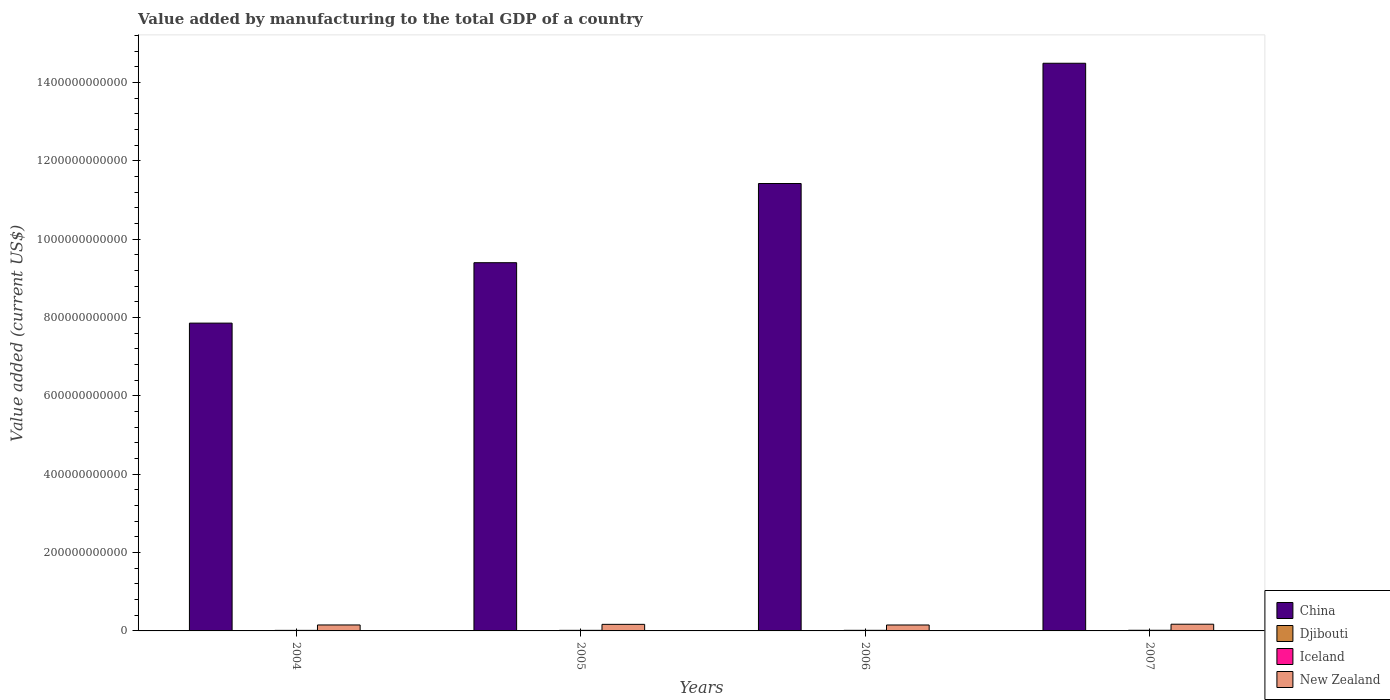How many different coloured bars are there?
Make the answer very short. 4. How many groups of bars are there?
Your response must be concise. 4. How many bars are there on the 1st tick from the right?
Offer a very short reply. 4. In how many cases, is the number of bars for a given year not equal to the number of legend labels?
Your answer should be compact. 0. What is the value added by manufacturing to the total GDP in Iceland in 2004?
Make the answer very short. 1.43e+09. Across all years, what is the maximum value added by manufacturing to the total GDP in Iceland?
Keep it short and to the point. 1.64e+09. Across all years, what is the minimum value added by manufacturing to the total GDP in New Zealand?
Make the answer very short. 1.51e+1. In which year was the value added by manufacturing to the total GDP in Djibouti minimum?
Offer a very short reply. 2004. What is the total value added by manufacturing to the total GDP in China in the graph?
Provide a short and direct response. 4.32e+12. What is the difference between the value added by manufacturing to the total GDP in Iceland in 2004 and that in 2007?
Your answer should be very brief. -2.09e+08. What is the difference between the value added by manufacturing to the total GDP in China in 2007 and the value added by manufacturing to the total GDP in Iceland in 2004?
Ensure brevity in your answer.  1.45e+12. What is the average value added by manufacturing to the total GDP in Djibouti per year?
Your answer should be compact. 1.68e+07. In the year 2007, what is the difference between the value added by manufacturing to the total GDP in Djibouti and value added by manufacturing to the total GDP in Iceland?
Offer a terse response. -1.62e+09. What is the ratio of the value added by manufacturing to the total GDP in Djibouti in 2005 to that in 2006?
Your response must be concise. 0.94. Is the value added by manufacturing to the total GDP in New Zealand in 2006 less than that in 2007?
Your answer should be compact. Yes. What is the difference between the highest and the second highest value added by manufacturing to the total GDP in New Zealand?
Your response must be concise. 3.70e+08. What is the difference between the highest and the lowest value added by manufacturing to the total GDP in Djibouti?
Ensure brevity in your answer.  2.88e+06. Is it the case that in every year, the sum of the value added by manufacturing to the total GDP in New Zealand and value added by manufacturing to the total GDP in Iceland is greater than the sum of value added by manufacturing to the total GDP in China and value added by manufacturing to the total GDP in Djibouti?
Your answer should be compact. Yes. What does the 1st bar from the right in 2004 represents?
Ensure brevity in your answer.  New Zealand. Is it the case that in every year, the sum of the value added by manufacturing to the total GDP in Djibouti and value added by manufacturing to the total GDP in New Zealand is greater than the value added by manufacturing to the total GDP in Iceland?
Offer a very short reply. Yes. How many bars are there?
Keep it short and to the point. 16. Are all the bars in the graph horizontal?
Your answer should be very brief. No. How many years are there in the graph?
Your response must be concise. 4. What is the difference between two consecutive major ticks on the Y-axis?
Give a very brief answer. 2.00e+11. Are the values on the major ticks of Y-axis written in scientific E-notation?
Provide a short and direct response. No. Does the graph contain any zero values?
Provide a succinct answer. No. Where does the legend appear in the graph?
Offer a terse response. Bottom right. What is the title of the graph?
Provide a short and direct response. Value added by manufacturing to the total GDP of a country. Does "Macao" appear as one of the legend labels in the graph?
Keep it short and to the point. No. What is the label or title of the X-axis?
Offer a terse response. Years. What is the label or title of the Y-axis?
Your answer should be very brief. Value added (current US$). What is the Value added (current US$) of China in 2004?
Provide a succinct answer. 7.86e+11. What is the Value added (current US$) in Djibouti in 2004?
Give a very brief answer. 1.54e+07. What is the Value added (current US$) in Iceland in 2004?
Your answer should be compact. 1.43e+09. What is the Value added (current US$) in New Zealand in 2004?
Your response must be concise. 1.52e+1. What is the Value added (current US$) in China in 2005?
Ensure brevity in your answer.  9.40e+11. What is the Value added (current US$) in Djibouti in 2005?
Provide a short and direct response. 1.63e+07. What is the Value added (current US$) of Iceland in 2005?
Make the answer very short. 1.48e+09. What is the Value added (current US$) of New Zealand in 2005?
Your answer should be very brief. 1.68e+1. What is the Value added (current US$) of China in 2006?
Offer a terse response. 1.14e+12. What is the Value added (current US$) of Djibouti in 2006?
Give a very brief answer. 1.73e+07. What is the Value added (current US$) of Iceland in 2006?
Keep it short and to the point. 1.51e+09. What is the Value added (current US$) in New Zealand in 2006?
Keep it short and to the point. 1.51e+1. What is the Value added (current US$) of China in 2007?
Your answer should be compact. 1.45e+12. What is the Value added (current US$) in Djibouti in 2007?
Your answer should be very brief. 1.83e+07. What is the Value added (current US$) in Iceland in 2007?
Ensure brevity in your answer.  1.64e+09. What is the Value added (current US$) in New Zealand in 2007?
Offer a very short reply. 1.71e+1. Across all years, what is the maximum Value added (current US$) in China?
Make the answer very short. 1.45e+12. Across all years, what is the maximum Value added (current US$) of Djibouti?
Make the answer very short. 1.83e+07. Across all years, what is the maximum Value added (current US$) in Iceland?
Give a very brief answer. 1.64e+09. Across all years, what is the maximum Value added (current US$) in New Zealand?
Offer a very short reply. 1.71e+1. Across all years, what is the minimum Value added (current US$) in China?
Give a very brief answer. 7.86e+11. Across all years, what is the minimum Value added (current US$) of Djibouti?
Your answer should be very brief. 1.54e+07. Across all years, what is the minimum Value added (current US$) of Iceland?
Provide a succinct answer. 1.43e+09. Across all years, what is the minimum Value added (current US$) of New Zealand?
Make the answer very short. 1.51e+1. What is the total Value added (current US$) in China in the graph?
Your response must be concise. 4.32e+12. What is the total Value added (current US$) of Djibouti in the graph?
Give a very brief answer. 6.73e+07. What is the total Value added (current US$) of Iceland in the graph?
Offer a terse response. 6.06e+09. What is the total Value added (current US$) of New Zealand in the graph?
Ensure brevity in your answer.  6.42e+1. What is the difference between the Value added (current US$) in China in 2004 and that in 2005?
Your answer should be very brief. -1.54e+11. What is the difference between the Value added (current US$) in Djibouti in 2004 and that in 2005?
Make the answer very short. -8.77e+05. What is the difference between the Value added (current US$) of Iceland in 2004 and that in 2005?
Provide a short and direct response. -5.56e+07. What is the difference between the Value added (current US$) of New Zealand in 2004 and that in 2005?
Your answer should be compact. -1.55e+09. What is the difference between the Value added (current US$) of China in 2004 and that in 2006?
Ensure brevity in your answer.  -3.56e+11. What is the difference between the Value added (current US$) of Djibouti in 2004 and that in 2006?
Offer a terse response. -1.83e+06. What is the difference between the Value added (current US$) of Iceland in 2004 and that in 2006?
Your response must be concise. -8.86e+07. What is the difference between the Value added (current US$) in New Zealand in 2004 and that in 2006?
Your response must be concise. 5.43e+07. What is the difference between the Value added (current US$) in China in 2004 and that in 2007?
Offer a very short reply. -6.63e+11. What is the difference between the Value added (current US$) in Djibouti in 2004 and that in 2007?
Keep it short and to the point. -2.88e+06. What is the difference between the Value added (current US$) of Iceland in 2004 and that in 2007?
Your response must be concise. -2.09e+08. What is the difference between the Value added (current US$) of New Zealand in 2004 and that in 2007?
Make the answer very short. -1.92e+09. What is the difference between the Value added (current US$) of China in 2005 and that in 2006?
Offer a terse response. -2.02e+11. What is the difference between the Value added (current US$) of Djibouti in 2005 and that in 2006?
Keep it short and to the point. -9.53e+05. What is the difference between the Value added (current US$) in Iceland in 2005 and that in 2006?
Offer a terse response. -3.30e+07. What is the difference between the Value added (current US$) of New Zealand in 2005 and that in 2006?
Your answer should be very brief. 1.61e+09. What is the difference between the Value added (current US$) in China in 2005 and that in 2007?
Provide a succinct answer. -5.09e+11. What is the difference between the Value added (current US$) of Djibouti in 2005 and that in 2007?
Your answer should be very brief. -2.00e+06. What is the difference between the Value added (current US$) of Iceland in 2005 and that in 2007?
Keep it short and to the point. -1.54e+08. What is the difference between the Value added (current US$) in New Zealand in 2005 and that in 2007?
Your answer should be very brief. -3.70e+08. What is the difference between the Value added (current US$) in China in 2006 and that in 2007?
Make the answer very short. -3.07e+11. What is the difference between the Value added (current US$) of Djibouti in 2006 and that in 2007?
Your answer should be compact. -1.05e+06. What is the difference between the Value added (current US$) in Iceland in 2006 and that in 2007?
Ensure brevity in your answer.  -1.21e+08. What is the difference between the Value added (current US$) of New Zealand in 2006 and that in 2007?
Ensure brevity in your answer.  -1.98e+09. What is the difference between the Value added (current US$) in China in 2004 and the Value added (current US$) in Djibouti in 2005?
Give a very brief answer. 7.86e+11. What is the difference between the Value added (current US$) in China in 2004 and the Value added (current US$) in Iceland in 2005?
Keep it short and to the point. 7.84e+11. What is the difference between the Value added (current US$) in China in 2004 and the Value added (current US$) in New Zealand in 2005?
Keep it short and to the point. 7.69e+11. What is the difference between the Value added (current US$) of Djibouti in 2004 and the Value added (current US$) of Iceland in 2005?
Ensure brevity in your answer.  -1.47e+09. What is the difference between the Value added (current US$) of Djibouti in 2004 and the Value added (current US$) of New Zealand in 2005?
Your response must be concise. -1.67e+1. What is the difference between the Value added (current US$) in Iceland in 2004 and the Value added (current US$) in New Zealand in 2005?
Provide a short and direct response. -1.53e+1. What is the difference between the Value added (current US$) in China in 2004 and the Value added (current US$) in Djibouti in 2006?
Offer a terse response. 7.86e+11. What is the difference between the Value added (current US$) in China in 2004 and the Value added (current US$) in Iceland in 2006?
Your response must be concise. 7.84e+11. What is the difference between the Value added (current US$) of China in 2004 and the Value added (current US$) of New Zealand in 2006?
Offer a very short reply. 7.71e+11. What is the difference between the Value added (current US$) in Djibouti in 2004 and the Value added (current US$) in Iceland in 2006?
Make the answer very short. -1.50e+09. What is the difference between the Value added (current US$) of Djibouti in 2004 and the Value added (current US$) of New Zealand in 2006?
Provide a succinct answer. -1.51e+1. What is the difference between the Value added (current US$) in Iceland in 2004 and the Value added (current US$) in New Zealand in 2006?
Provide a succinct answer. -1.37e+1. What is the difference between the Value added (current US$) in China in 2004 and the Value added (current US$) in Djibouti in 2007?
Your response must be concise. 7.86e+11. What is the difference between the Value added (current US$) of China in 2004 and the Value added (current US$) of Iceland in 2007?
Provide a short and direct response. 7.84e+11. What is the difference between the Value added (current US$) in China in 2004 and the Value added (current US$) in New Zealand in 2007?
Make the answer very short. 7.69e+11. What is the difference between the Value added (current US$) in Djibouti in 2004 and the Value added (current US$) in Iceland in 2007?
Offer a terse response. -1.62e+09. What is the difference between the Value added (current US$) of Djibouti in 2004 and the Value added (current US$) of New Zealand in 2007?
Give a very brief answer. -1.71e+1. What is the difference between the Value added (current US$) of Iceland in 2004 and the Value added (current US$) of New Zealand in 2007?
Your answer should be compact. -1.57e+1. What is the difference between the Value added (current US$) in China in 2005 and the Value added (current US$) in Djibouti in 2006?
Offer a terse response. 9.40e+11. What is the difference between the Value added (current US$) in China in 2005 and the Value added (current US$) in Iceland in 2006?
Give a very brief answer. 9.39e+11. What is the difference between the Value added (current US$) of China in 2005 and the Value added (current US$) of New Zealand in 2006?
Ensure brevity in your answer.  9.25e+11. What is the difference between the Value added (current US$) in Djibouti in 2005 and the Value added (current US$) in Iceland in 2006?
Provide a succinct answer. -1.50e+09. What is the difference between the Value added (current US$) of Djibouti in 2005 and the Value added (current US$) of New Zealand in 2006?
Your answer should be compact. -1.51e+1. What is the difference between the Value added (current US$) in Iceland in 2005 and the Value added (current US$) in New Zealand in 2006?
Your answer should be very brief. -1.37e+1. What is the difference between the Value added (current US$) in China in 2005 and the Value added (current US$) in Djibouti in 2007?
Offer a terse response. 9.40e+11. What is the difference between the Value added (current US$) of China in 2005 and the Value added (current US$) of Iceland in 2007?
Offer a very short reply. 9.38e+11. What is the difference between the Value added (current US$) of China in 2005 and the Value added (current US$) of New Zealand in 2007?
Your answer should be very brief. 9.23e+11. What is the difference between the Value added (current US$) of Djibouti in 2005 and the Value added (current US$) of Iceland in 2007?
Ensure brevity in your answer.  -1.62e+09. What is the difference between the Value added (current US$) of Djibouti in 2005 and the Value added (current US$) of New Zealand in 2007?
Offer a very short reply. -1.71e+1. What is the difference between the Value added (current US$) in Iceland in 2005 and the Value added (current US$) in New Zealand in 2007?
Offer a terse response. -1.56e+1. What is the difference between the Value added (current US$) in China in 2006 and the Value added (current US$) in Djibouti in 2007?
Make the answer very short. 1.14e+12. What is the difference between the Value added (current US$) in China in 2006 and the Value added (current US$) in Iceland in 2007?
Your answer should be compact. 1.14e+12. What is the difference between the Value added (current US$) in China in 2006 and the Value added (current US$) in New Zealand in 2007?
Offer a very short reply. 1.13e+12. What is the difference between the Value added (current US$) in Djibouti in 2006 and the Value added (current US$) in Iceland in 2007?
Your answer should be very brief. -1.62e+09. What is the difference between the Value added (current US$) in Djibouti in 2006 and the Value added (current US$) in New Zealand in 2007?
Your answer should be compact. -1.71e+1. What is the difference between the Value added (current US$) of Iceland in 2006 and the Value added (current US$) of New Zealand in 2007?
Offer a very short reply. -1.56e+1. What is the average Value added (current US$) in China per year?
Your answer should be very brief. 1.08e+12. What is the average Value added (current US$) in Djibouti per year?
Your response must be concise. 1.68e+07. What is the average Value added (current US$) of Iceland per year?
Keep it short and to the point. 1.51e+09. What is the average Value added (current US$) in New Zealand per year?
Your answer should be very brief. 1.61e+1. In the year 2004, what is the difference between the Value added (current US$) of China and Value added (current US$) of Djibouti?
Offer a terse response. 7.86e+11. In the year 2004, what is the difference between the Value added (current US$) of China and Value added (current US$) of Iceland?
Your answer should be very brief. 7.84e+11. In the year 2004, what is the difference between the Value added (current US$) in China and Value added (current US$) in New Zealand?
Ensure brevity in your answer.  7.71e+11. In the year 2004, what is the difference between the Value added (current US$) in Djibouti and Value added (current US$) in Iceland?
Offer a terse response. -1.41e+09. In the year 2004, what is the difference between the Value added (current US$) in Djibouti and Value added (current US$) in New Zealand?
Provide a short and direct response. -1.52e+1. In the year 2004, what is the difference between the Value added (current US$) in Iceland and Value added (current US$) in New Zealand?
Offer a very short reply. -1.38e+1. In the year 2005, what is the difference between the Value added (current US$) in China and Value added (current US$) in Djibouti?
Provide a succinct answer. 9.40e+11. In the year 2005, what is the difference between the Value added (current US$) in China and Value added (current US$) in Iceland?
Your answer should be compact. 9.39e+11. In the year 2005, what is the difference between the Value added (current US$) of China and Value added (current US$) of New Zealand?
Offer a very short reply. 9.23e+11. In the year 2005, what is the difference between the Value added (current US$) in Djibouti and Value added (current US$) in Iceland?
Your response must be concise. -1.47e+09. In the year 2005, what is the difference between the Value added (current US$) of Djibouti and Value added (current US$) of New Zealand?
Give a very brief answer. -1.67e+1. In the year 2005, what is the difference between the Value added (current US$) of Iceland and Value added (current US$) of New Zealand?
Your answer should be compact. -1.53e+1. In the year 2006, what is the difference between the Value added (current US$) in China and Value added (current US$) in Djibouti?
Provide a short and direct response. 1.14e+12. In the year 2006, what is the difference between the Value added (current US$) of China and Value added (current US$) of Iceland?
Keep it short and to the point. 1.14e+12. In the year 2006, what is the difference between the Value added (current US$) in China and Value added (current US$) in New Zealand?
Your answer should be compact. 1.13e+12. In the year 2006, what is the difference between the Value added (current US$) in Djibouti and Value added (current US$) in Iceland?
Keep it short and to the point. -1.50e+09. In the year 2006, what is the difference between the Value added (current US$) of Djibouti and Value added (current US$) of New Zealand?
Ensure brevity in your answer.  -1.51e+1. In the year 2006, what is the difference between the Value added (current US$) in Iceland and Value added (current US$) in New Zealand?
Give a very brief answer. -1.36e+1. In the year 2007, what is the difference between the Value added (current US$) in China and Value added (current US$) in Djibouti?
Your response must be concise. 1.45e+12. In the year 2007, what is the difference between the Value added (current US$) of China and Value added (current US$) of Iceland?
Make the answer very short. 1.45e+12. In the year 2007, what is the difference between the Value added (current US$) of China and Value added (current US$) of New Zealand?
Provide a short and direct response. 1.43e+12. In the year 2007, what is the difference between the Value added (current US$) in Djibouti and Value added (current US$) in Iceland?
Offer a very short reply. -1.62e+09. In the year 2007, what is the difference between the Value added (current US$) in Djibouti and Value added (current US$) in New Zealand?
Offer a terse response. -1.71e+1. In the year 2007, what is the difference between the Value added (current US$) of Iceland and Value added (current US$) of New Zealand?
Offer a very short reply. -1.55e+1. What is the ratio of the Value added (current US$) in China in 2004 to that in 2005?
Give a very brief answer. 0.84. What is the ratio of the Value added (current US$) of Djibouti in 2004 to that in 2005?
Provide a short and direct response. 0.95. What is the ratio of the Value added (current US$) in Iceland in 2004 to that in 2005?
Make the answer very short. 0.96. What is the ratio of the Value added (current US$) of New Zealand in 2004 to that in 2005?
Make the answer very short. 0.91. What is the ratio of the Value added (current US$) in China in 2004 to that in 2006?
Offer a terse response. 0.69. What is the ratio of the Value added (current US$) of Djibouti in 2004 to that in 2006?
Ensure brevity in your answer.  0.89. What is the ratio of the Value added (current US$) of Iceland in 2004 to that in 2006?
Provide a succinct answer. 0.94. What is the ratio of the Value added (current US$) of China in 2004 to that in 2007?
Offer a terse response. 0.54. What is the ratio of the Value added (current US$) in Djibouti in 2004 to that in 2007?
Provide a succinct answer. 0.84. What is the ratio of the Value added (current US$) in Iceland in 2004 to that in 2007?
Your response must be concise. 0.87. What is the ratio of the Value added (current US$) of New Zealand in 2004 to that in 2007?
Provide a succinct answer. 0.89. What is the ratio of the Value added (current US$) in China in 2005 to that in 2006?
Keep it short and to the point. 0.82. What is the ratio of the Value added (current US$) in Djibouti in 2005 to that in 2006?
Provide a short and direct response. 0.94. What is the ratio of the Value added (current US$) of Iceland in 2005 to that in 2006?
Your answer should be very brief. 0.98. What is the ratio of the Value added (current US$) in New Zealand in 2005 to that in 2006?
Your response must be concise. 1.11. What is the ratio of the Value added (current US$) in China in 2005 to that in 2007?
Make the answer very short. 0.65. What is the ratio of the Value added (current US$) in Djibouti in 2005 to that in 2007?
Give a very brief answer. 0.89. What is the ratio of the Value added (current US$) in Iceland in 2005 to that in 2007?
Keep it short and to the point. 0.91. What is the ratio of the Value added (current US$) in New Zealand in 2005 to that in 2007?
Provide a short and direct response. 0.98. What is the ratio of the Value added (current US$) in China in 2006 to that in 2007?
Keep it short and to the point. 0.79. What is the ratio of the Value added (current US$) in Djibouti in 2006 to that in 2007?
Make the answer very short. 0.94. What is the ratio of the Value added (current US$) in Iceland in 2006 to that in 2007?
Your answer should be very brief. 0.93. What is the ratio of the Value added (current US$) in New Zealand in 2006 to that in 2007?
Give a very brief answer. 0.88. What is the difference between the highest and the second highest Value added (current US$) of China?
Provide a short and direct response. 3.07e+11. What is the difference between the highest and the second highest Value added (current US$) of Djibouti?
Give a very brief answer. 1.05e+06. What is the difference between the highest and the second highest Value added (current US$) of Iceland?
Make the answer very short. 1.21e+08. What is the difference between the highest and the second highest Value added (current US$) in New Zealand?
Make the answer very short. 3.70e+08. What is the difference between the highest and the lowest Value added (current US$) of China?
Provide a succinct answer. 6.63e+11. What is the difference between the highest and the lowest Value added (current US$) in Djibouti?
Give a very brief answer. 2.88e+06. What is the difference between the highest and the lowest Value added (current US$) in Iceland?
Your response must be concise. 2.09e+08. What is the difference between the highest and the lowest Value added (current US$) in New Zealand?
Offer a terse response. 1.98e+09. 